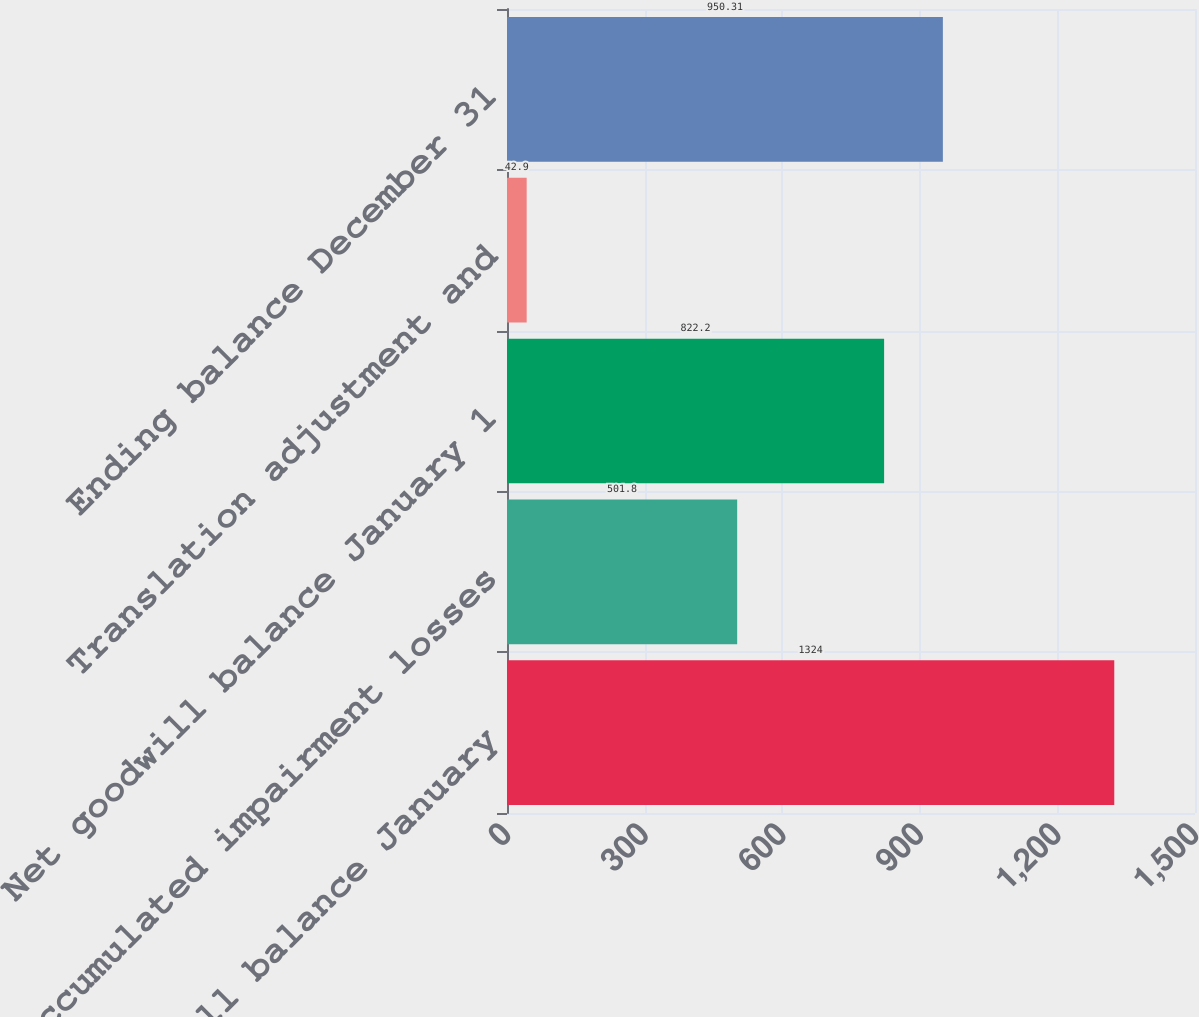Convert chart. <chart><loc_0><loc_0><loc_500><loc_500><bar_chart><fcel>Gross goodwill balance January<fcel>Accumulated impairment losses<fcel>Net goodwill balance January 1<fcel>Translation adjustment and<fcel>Ending balance December 31<nl><fcel>1324<fcel>501.8<fcel>822.2<fcel>42.9<fcel>950.31<nl></chart> 